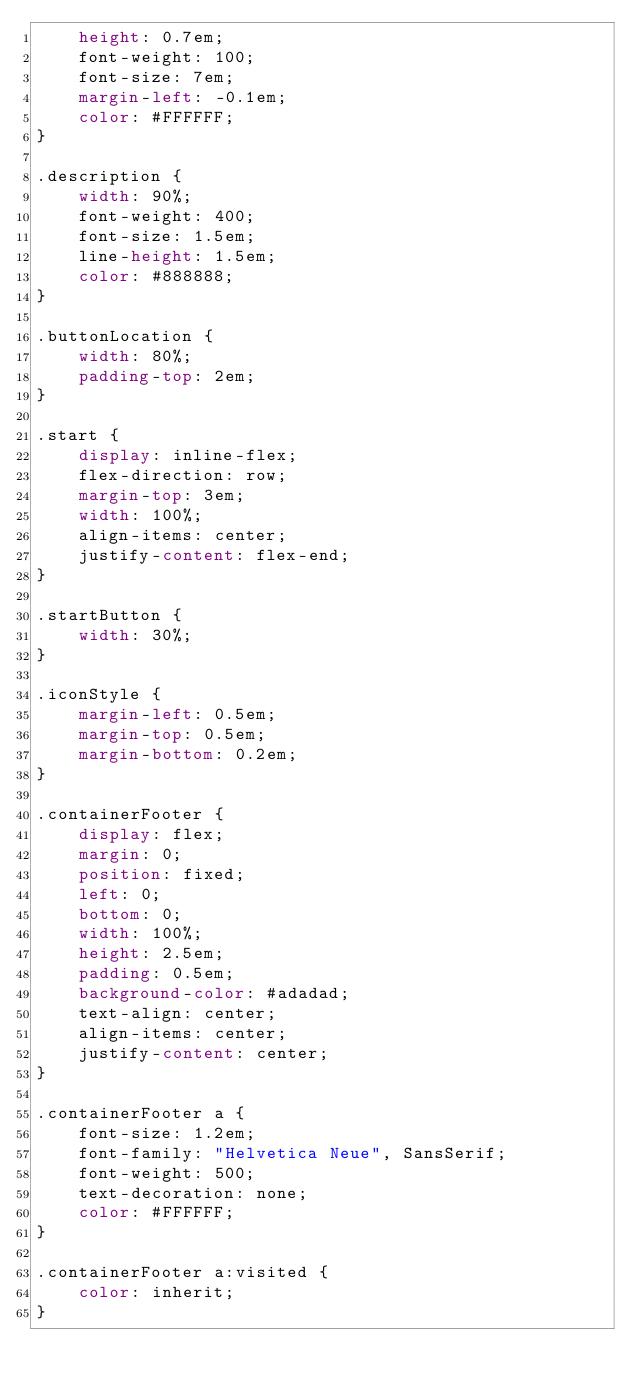Convert code to text. <code><loc_0><loc_0><loc_500><loc_500><_CSS_>    height: 0.7em;
    font-weight: 100;
    font-size: 7em;
    margin-left: -0.1em;
    color: #FFFFFF;
}

.description {
    width: 90%;
    font-weight: 400;
    font-size: 1.5em;
    line-height: 1.5em;
    color: #888888;
}

.buttonLocation {
    width: 80%;
    padding-top: 2em;
}

.start {
    display: inline-flex;
    flex-direction: row;
    margin-top: 3em;
    width: 100%;
    align-items: center;
    justify-content: flex-end;
}

.startButton {
    width: 30%;
}

.iconStyle {
    margin-left: 0.5em;
    margin-top: 0.5em;
    margin-bottom: 0.2em;
}

.containerFooter {
    display: flex;
    margin: 0;
    position: fixed;
    left: 0;
    bottom: 0;
    width: 100%;
    height: 2.5em;
    padding: 0.5em;
    background-color: #adadad;
    text-align: center;
    align-items: center;
    justify-content: center;
}

.containerFooter a {
    font-size: 1.2em;
    font-family: "Helvetica Neue", SansSerif;
    font-weight: 500;
    text-decoration: none;
    color: #FFFFFF;
}

.containerFooter a:visited {
    color: inherit;
}
</code> 